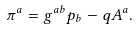Convert formula to latex. <formula><loc_0><loc_0><loc_500><loc_500>\pi ^ { a } = g ^ { a b } p _ { b } - q A ^ { a } .</formula> 